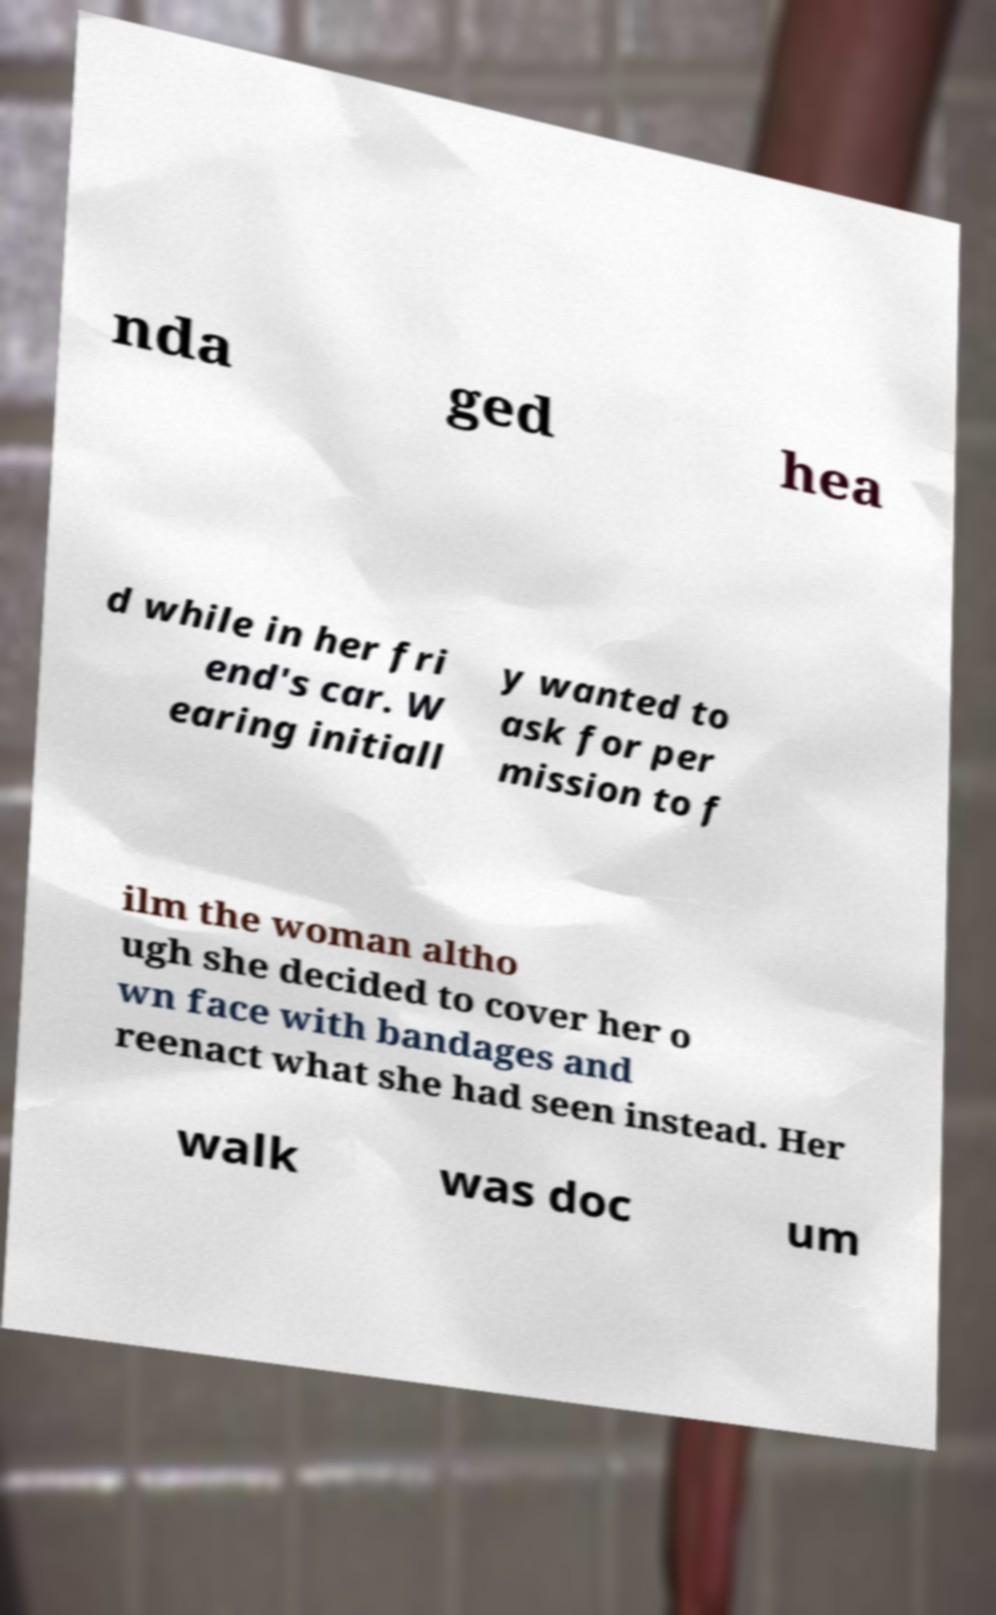Can you read and provide the text displayed in the image?This photo seems to have some interesting text. Can you extract and type it out for me? nda ged hea d while in her fri end's car. W earing initiall y wanted to ask for per mission to f ilm the woman altho ugh she decided to cover her o wn face with bandages and reenact what she had seen instead. Her walk was doc um 